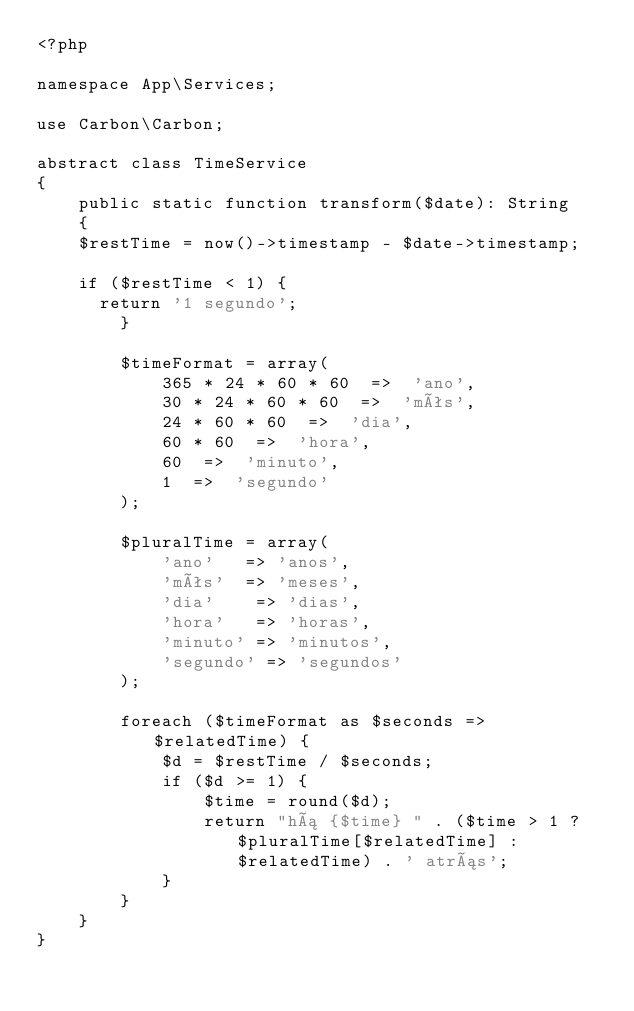Convert code to text. <code><loc_0><loc_0><loc_500><loc_500><_PHP_><?php

namespace App\Services;

use Carbon\Carbon;

abstract class TimeService
{
    public static function transform($date): String
    {
		$restTime = now()->timestamp - $date->timestamp;

		if ($restTime < 1) {
			return '1 segundo';
        }

        $timeFormat = array(
            365 * 24 * 60 * 60  =>  'ano',
            30 * 24 * 60 * 60  =>  'mês',
            24 * 60 * 60  =>  'dia',
            60 * 60  =>  'hora',
            60  =>  'minuto',
            1  =>  'segundo'
        );

        $pluralTime = array(
            'ano'   => 'anos',
            'mês'  => 'meses',
            'dia'    => 'dias',
            'hora'   => 'horas',
            'minuto' => 'minutos',
            'segundo' => 'segundos'
        );

        foreach ($timeFormat as $seconds => $relatedTime) {
            $d = $restTime / $seconds;
            if ($d >= 1) {
                $time = round($d);
                return "há {$time} " . ($time > 1 ? $pluralTime[$relatedTime] : $relatedTime) . ' atrás';
            }
        }
    }
}
</code> 